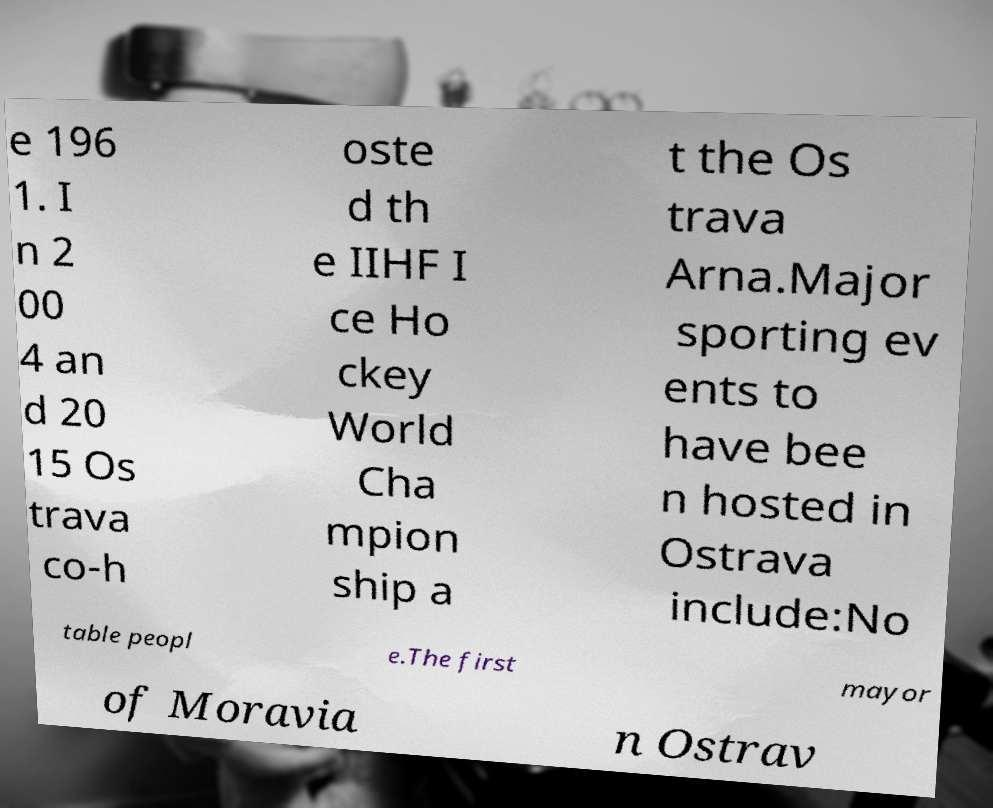Could you extract and type out the text from this image? e 196 1. I n 2 00 4 an d 20 15 Os trava co-h oste d th e IIHF I ce Ho ckey World Cha mpion ship a t the Os trava Arna.Major sporting ev ents to have bee n hosted in Ostrava include:No table peopl e.The first mayor of Moravia n Ostrav 